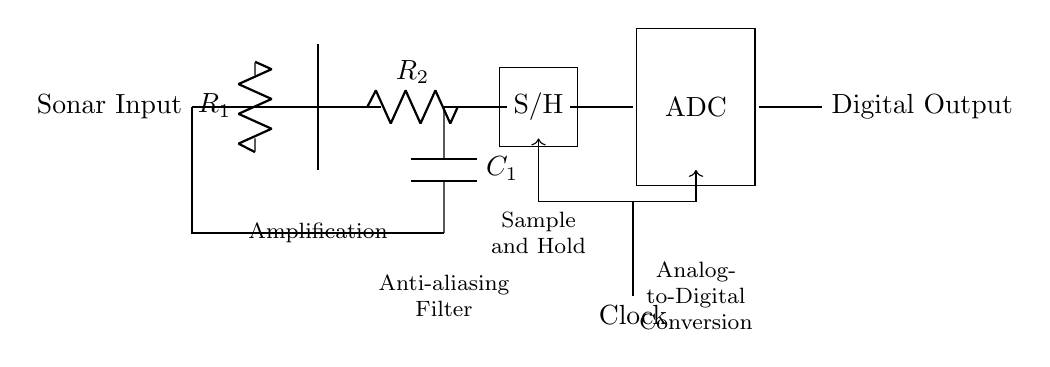What is the first component in the circuit? The first component shown in the circuit diagram is labeled as "Sonar Input," indicating the initial signal source.
Answer: Sonar Input What does "S/H" stand for in this circuit? "S/H" stands for Sample and Hold, which is a key component used to capture and hold the value of the analog signal for conversion.
Answer: Sample and Hold What type of filter is implemented after the amplifier? A low-pass filter is implemented after the amplifier, as indicated by the components labeled R2 and C1 which form the filter circuit.
Answer: Low-pass filter What role does the clock play in the ADC operation? The clock provides timing signals necessary for the Analog-to-Digital Converter to sample the analog input at defined intervals, ensuring accurate and synchronized conversion.
Answer: Timing signals What is the function of the operational amplifier in this circuit? The operational amplifier amplifies the sonar input signal, increasing its magnitude before processing it further in the circuit.
Answer: Amplification How does the anti-aliasing filter affect the signal? The anti-aliasing filter, represented by the resistor and capacitor in the circuit, removes high-frequency noise from the signal, preventing distortion during the digitization process.
Answer: Removes high-frequency noise What does the label "ADC" signify, and what is its function? The label "ADC" signifies the Analog-to-Digital Converter, which is responsible for converting the amplified and conditioned analog signal into a digital representation for further processing.
Answer: Analog-to-Digital Converter 